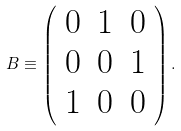<formula> <loc_0><loc_0><loc_500><loc_500>B \equiv \left ( \begin{array} { l l l } 0 & 1 & 0 \\ 0 & 0 & 1 \\ 1 & 0 & 0 \end{array} \right ) .</formula> 